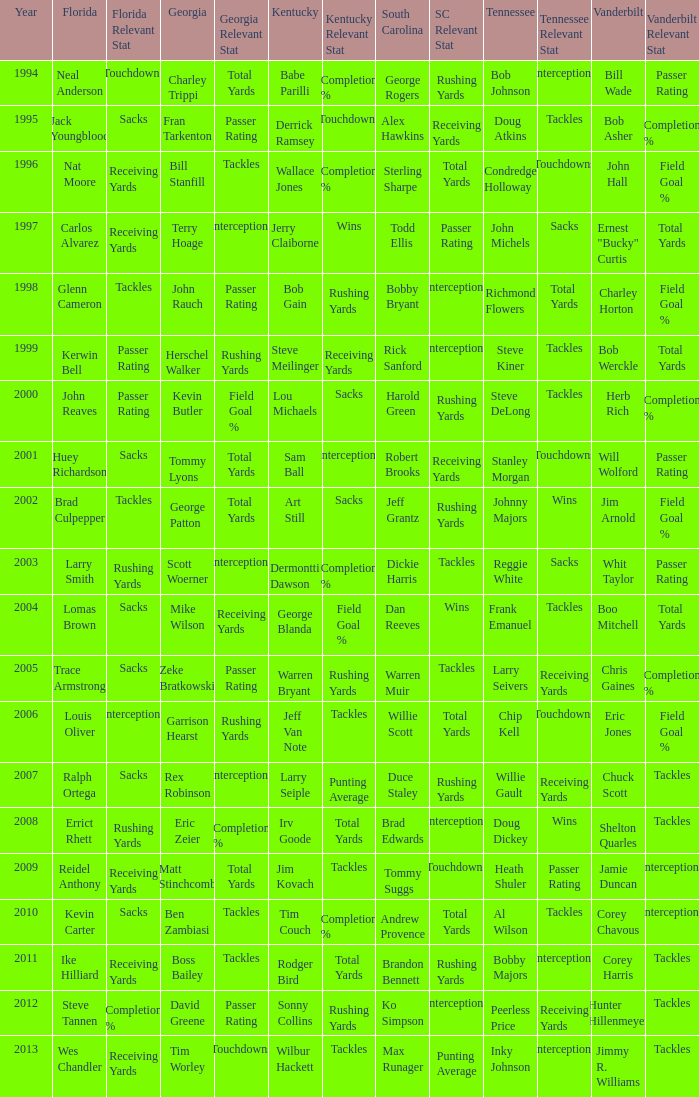Help me parse the entirety of this table. {'header': ['Year', 'Florida', 'Florida Relevant Stat', 'Georgia', 'Georgia Relevant Stat', 'Kentucky', 'Kentucky Relevant Stat', 'South Carolina', 'SC Relevant Stat', 'Tennessee', 'Tennessee Relevant Stat', 'Vanderbilt', 'Vanderbilt Relevant Stat'], 'rows': [['1994', 'Neal Anderson', 'Touchdowns', 'Charley Trippi', 'Total Yards', 'Babe Parilli', 'Completion %', 'George Rogers', 'Rushing Yards', 'Bob Johnson', 'Interceptions', 'Bill Wade', 'Passer Rating'], ['1995', 'Jack Youngblood', 'Sacks', 'Fran Tarkenton', 'Passer Rating', 'Derrick Ramsey', 'Touchdowns', 'Alex Hawkins', 'Receiving Yards', 'Doug Atkins', 'Tackles', 'Bob Asher', 'Completion %'], ['1996', 'Nat Moore', 'Receiving Yards', 'Bill Stanfill', 'Tackles', 'Wallace Jones', 'Completion %', 'Sterling Sharpe', 'Total Yards', 'Condredge Holloway', 'Touchdowns', 'John Hall', 'Field Goal %'], ['1997', 'Carlos Alvarez', 'Receiving Yards', 'Terry Hoage', 'Interceptions', 'Jerry Claiborne', 'Wins', 'Todd Ellis', 'Passer Rating', 'John Michels', 'Sacks', 'Ernest "Bucky" Curtis', 'Total Yards'], ['1998', 'Glenn Cameron', 'Tackles', 'John Rauch', 'Passer Rating', 'Bob Gain', 'Rushing Yards', 'Bobby Bryant', 'Interceptions', 'Richmond Flowers', 'Total Yards', 'Charley Horton', 'Field Goal %'], ['1999', 'Kerwin Bell', 'Passer Rating', 'Herschel Walker', 'Rushing Yards', 'Steve Meilinger', 'Receiving Yards', 'Rick Sanford', 'Interceptions', 'Steve Kiner', 'Tackles', 'Bob Werckle', 'Total Yards'], ['2000', 'John Reaves', 'Passer Rating', 'Kevin Butler', 'Field Goal %', 'Lou Michaels', 'Sacks', 'Harold Green', 'Rushing Yards', 'Steve DeLong', 'Tackles', 'Herb Rich', 'Completion %'], ['2001', 'Huey Richardson', 'Sacks', 'Tommy Lyons', 'Total Yards', 'Sam Ball', 'Interceptions', 'Robert Brooks', 'Receiving Yards', 'Stanley Morgan', 'Touchdowns', 'Will Wolford', 'Passer Rating'], ['2002', 'Brad Culpepper', 'Tackles', 'George Patton', 'Total Yards', 'Art Still', 'Sacks', 'Jeff Grantz', 'Rushing Yards', 'Johnny Majors', 'Wins', 'Jim Arnold', 'Field Goal %'], ['2003', 'Larry Smith', 'Rushing Yards', 'Scott Woerner', 'Interceptions', 'Dermontti Dawson', 'Completion %', 'Dickie Harris', 'Tackles', 'Reggie White', 'Sacks', 'Whit Taylor', 'Passer Rating'], ['2004', 'Lomas Brown', 'Sacks', 'Mike Wilson', 'Receiving Yards', 'George Blanda', 'Field Goal %', 'Dan Reeves', 'Wins', 'Frank Emanuel', 'Tackles', 'Boo Mitchell', 'Total Yards'], ['2005', 'Trace Armstrong', 'Sacks', 'Zeke Bratkowski', 'Passer Rating', 'Warren Bryant', 'Rushing Yards', 'Warren Muir', 'Tackles', 'Larry Seivers', 'Receiving Yards', 'Chris Gaines', 'Completion %'], ['2006', 'Louis Oliver', 'Interceptions', 'Garrison Hearst', 'Rushing Yards', 'Jeff Van Note', 'Tackles', 'Willie Scott', 'Total Yards', 'Chip Kell', 'Touchdowns', 'Eric Jones', 'Field Goal %'], ['2007', 'Ralph Ortega', 'Sacks', 'Rex Robinson', 'Interceptions', 'Larry Seiple', 'Punting Average', 'Duce Staley', 'Rushing Yards', 'Willie Gault', 'Receiving Yards', 'Chuck Scott', 'Tackles'], ['2008', 'Errict Rhett', 'Rushing Yards', 'Eric Zeier', 'Completion %', 'Irv Goode', 'Total Yards', 'Brad Edwards', 'Interceptions', 'Doug Dickey', 'Wins', 'Shelton Quarles', 'Tackles'], ['2009', 'Reidel Anthony', 'Receiving Yards', 'Matt Stinchcomb', 'Total Yards', 'Jim Kovach', 'Tackles', 'Tommy Suggs', 'Touchdowns', 'Heath Shuler', 'Passer Rating', 'Jamie Duncan', 'Interceptions'], ['2010', 'Kevin Carter', 'Sacks', 'Ben Zambiasi', 'Tackles', 'Tim Couch', 'Completion %', 'Andrew Provence', 'Total Yards', 'Al Wilson', 'Tackles', 'Corey Chavous', 'Interceptions'], ['2011', 'Ike Hilliard', 'Receiving Yards', 'Boss Bailey', 'Tackles', 'Rodger Bird', 'Total Yards', 'Brandon Bennett', 'Rushing Yards', 'Bobby Majors', 'Interceptions', 'Corey Harris', 'Tackles'], ['2012', 'Steve Tannen', 'Completion %', 'David Greene', 'Passer Rating', 'Sonny Collins', 'Rushing Yards', 'Ko Simpson', 'Interceptions', 'Peerless Price', 'Receiving Yards', 'Hunter Hillenmeyer', 'Tackles'], ['2013', 'Wes Chandler', 'Receiving Yards', 'Tim Worley', 'Touchdowns', 'Wilbur Hackett', 'Tackles', 'Max Runager', 'Punting Average', 'Inky Johnson', 'Interceptions', 'Jimmy R. Williams', 'Tackles']]} What is the total Year of jeff van note ( Kentucky) 2006.0. 